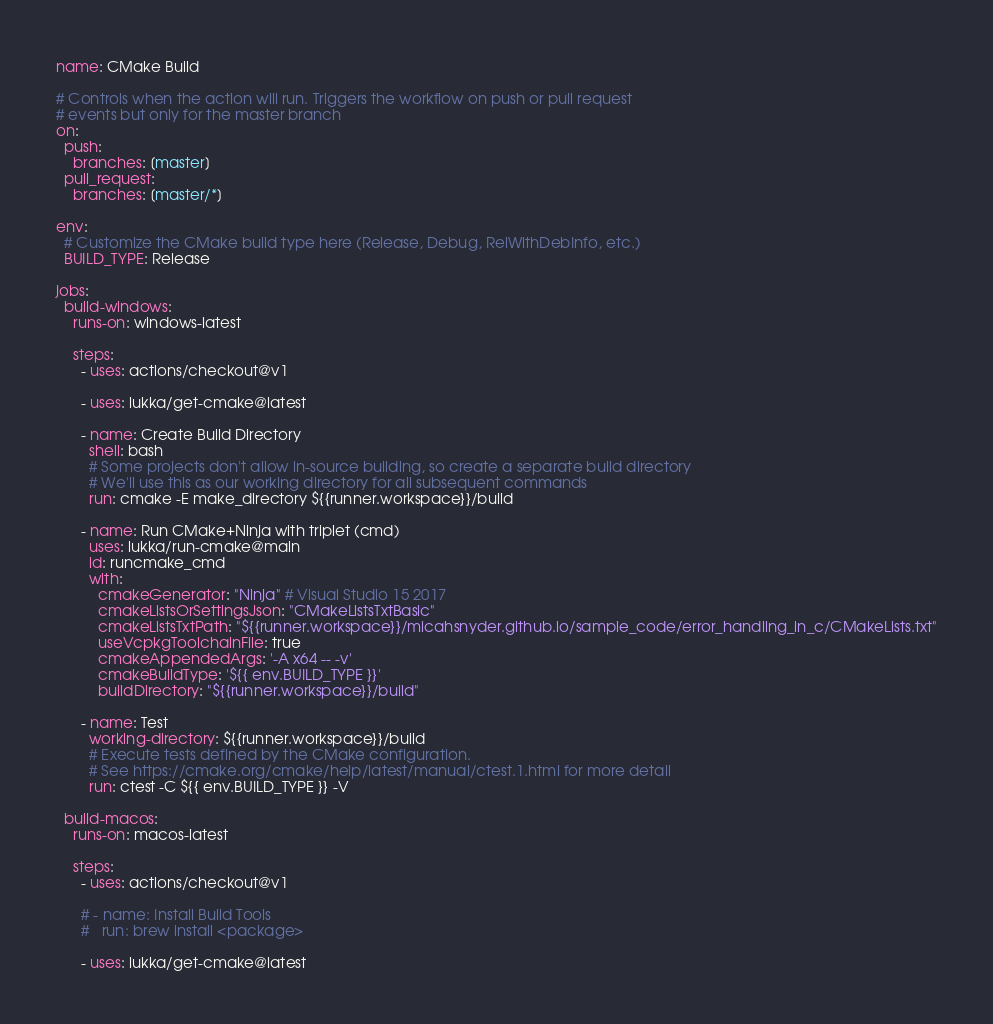<code> <loc_0><loc_0><loc_500><loc_500><_YAML_>name: CMake Build

# Controls when the action will run. Triggers the workflow on push or pull request
# events but only for the master branch
on:
  push:
    branches: [master]
  pull_request:
    branches: [master/*]

env:
  # Customize the CMake build type here (Release, Debug, RelWithDebInfo, etc.)
  BUILD_TYPE: Release

jobs:
  build-windows:
    runs-on: windows-latest

    steps:
      - uses: actions/checkout@v1

      - uses: lukka/get-cmake@latest

      - name: Create Build Directory
        shell: bash
        # Some projects don't allow in-source building, so create a separate build directory
        # We'll use this as our working directory for all subsequent commands
        run: cmake -E make_directory ${{runner.workspace}}/build

      - name: Run CMake+Ninja with triplet (cmd)
        uses: lukka/run-cmake@main
        id: runcmake_cmd
        with:
          cmakeGenerator: "Ninja" # Visual Studio 15 2017
          cmakeListsOrSettingsJson: "CMakeListsTxtBasic"
          cmakeListsTxtPath: "${{runner.workspace}}/micahsnyder.github.io/sample_code/error_handling_in_c/CMakeLists.txt"
          useVcpkgToolchainFile: true
          cmakeAppendedArgs: '-A x64 -- -v'
          cmakeBuildType: '${{ env.BUILD_TYPE }}'
          buildDirectory: "${{runner.workspace}}/build"

      - name: Test
        working-directory: ${{runner.workspace}}/build
        # Execute tests defined by the CMake configuration.
        # See https://cmake.org/cmake/help/latest/manual/ctest.1.html for more detail
        run: ctest -C ${{ env.BUILD_TYPE }} -V

  build-macos:
    runs-on: macos-latest

    steps:
      - uses: actions/checkout@v1

      # - name: Install Build Tools
      #   run: brew install <package>

      - uses: lukka/get-cmake@latest
</code> 